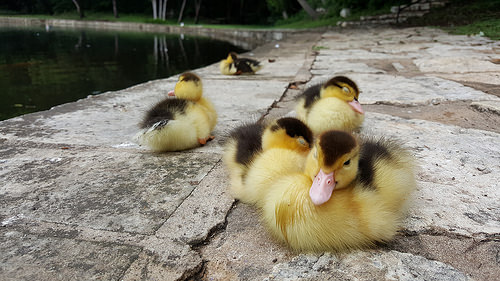<image>
Is the baby one on the baby two? Yes. Looking at the image, I can see the baby one is positioned on top of the baby two, with the baby two providing support. Where is the chick in relation to the chick? Is it in front of the chick? No. The chick is not in front of the chick. The spatial positioning shows a different relationship between these objects. 